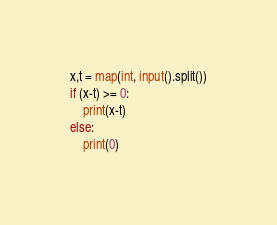Convert code to text. <code><loc_0><loc_0><loc_500><loc_500><_Python_>x,t = map(int, input().split())
if (x-t) >= 0:
    print(x-t)
else:
    print(0)</code> 